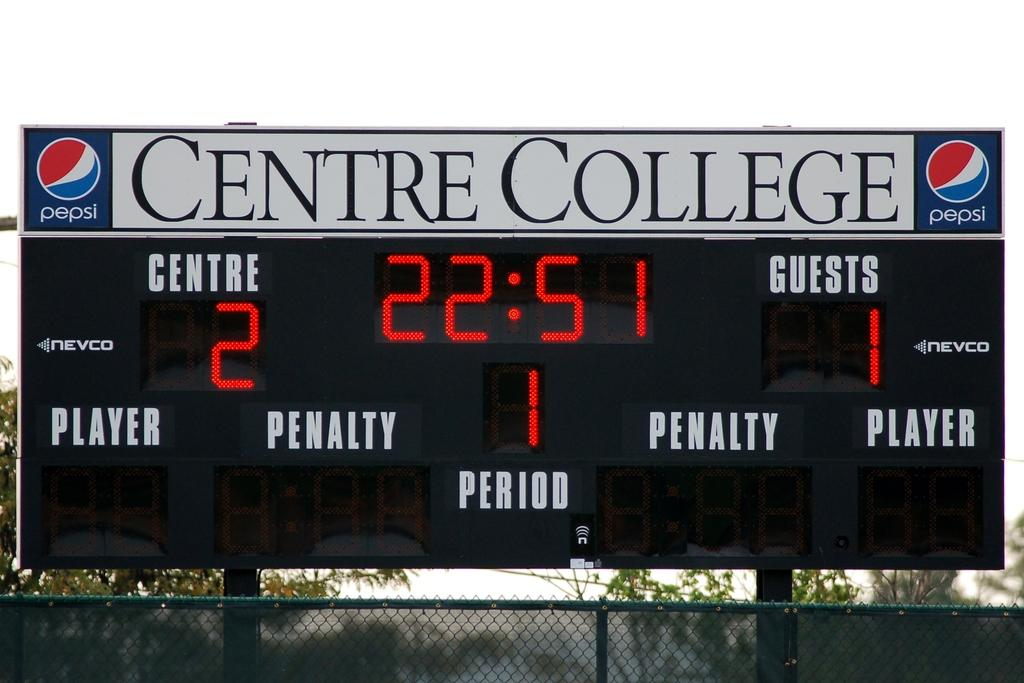<image>
Write a terse but informative summary of the picture. The score is 2 to 1 on the Centre College scoreboard. 